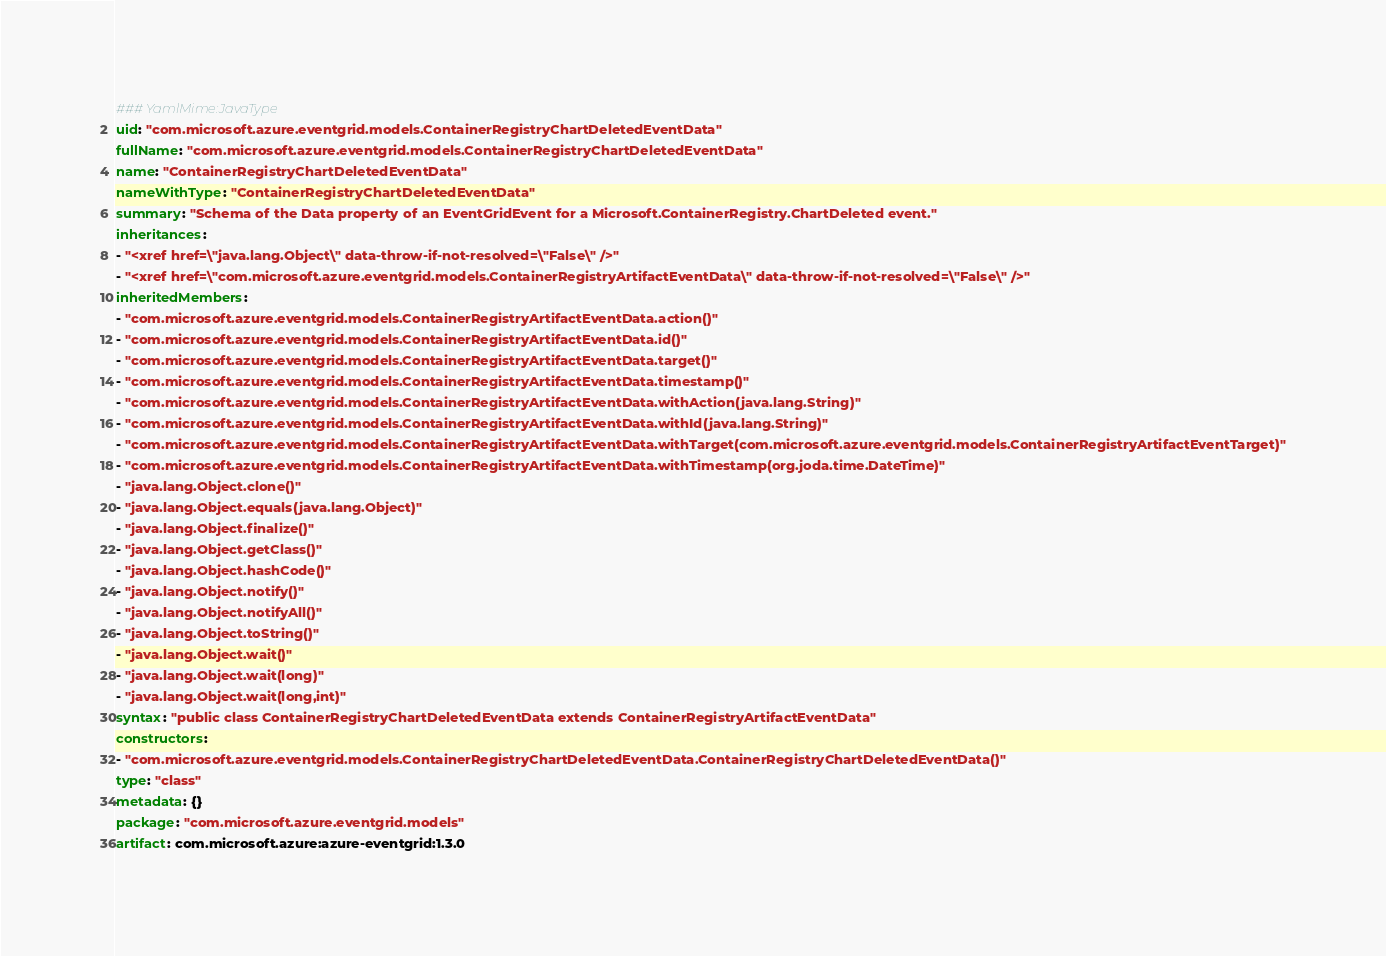<code> <loc_0><loc_0><loc_500><loc_500><_YAML_>### YamlMime:JavaType
uid: "com.microsoft.azure.eventgrid.models.ContainerRegistryChartDeletedEventData"
fullName: "com.microsoft.azure.eventgrid.models.ContainerRegistryChartDeletedEventData"
name: "ContainerRegistryChartDeletedEventData"
nameWithType: "ContainerRegistryChartDeletedEventData"
summary: "Schema of the Data property of an EventGridEvent for a Microsoft.ContainerRegistry.ChartDeleted event."
inheritances:
- "<xref href=\"java.lang.Object\" data-throw-if-not-resolved=\"False\" />"
- "<xref href=\"com.microsoft.azure.eventgrid.models.ContainerRegistryArtifactEventData\" data-throw-if-not-resolved=\"False\" />"
inheritedMembers:
- "com.microsoft.azure.eventgrid.models.ContainerRegistryArtifactEventData.action()"
- "com.microsoft.azure.eventgrid.models.ContainerRegistryArtifactEventData.id()"
- "com.microsoft.azure.eventgrid.models.ContainerRegistryArtifactEventData.target()"
- "com.microsoft.azure.eventgrid.models.ContainerRegistryArtifactEventData.timestamp()"
- "com.microsoft.azure.eventgrid.models.ContainerRegistryArtifactEventData.withAction(java.lang.String)"
- "com.microsoft.azure.eventgrid.models.ContainerRegistryArtifactEventData.withId(java.lang.String)"
- "com.microsoft.azure.eventgrid.models.ContainerRegistryArtifactEventData.withTarget(com.microsoft.azure.eventgrid.models.ContainerRegistryArtifactEventTarget)"
- "com.microsoft.azure.eventgrid.models.ContainerRegistryArtifactEventData.withTimestamp(org.joda.time.DateTime)"
- "java.lang.Object.clone()"
- "java.lang.Object.equals(java.lang.Object)"
- "java.lang.Object.finalize()"
- "java.lang.Object.getClass()"
- "java.lang.Object.hashCode()"
- "java.lang.Object.notify()"
- "java.lang.Object.notifyAll()"
- "java.lang.Object.toString()"
- "java.lang.Object.wait()"
- "java.lang.Object.wait(long)"
- "java.lang.Object.wait(long,int)"
syntax: "public class ContainerRegistryChartDeletedEventData extends ContainerRegistryArtifactEventData"
constructors:
- "com.microsoft.azure.eventgrid.models.ContainerRegistryChartDeletedEventData.ContainerRegistryChartDeletedEventData()"
type: "class"
metadata: {}
package: "com.microsoft.azure.eventgrid.models"
artifact: com.microsoft.azure:azure-eventgrid:1.3.0
</code> 